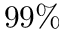<formula> <loc_0><loc_0><loc_500><loc_500>9 9 \%</formula> 